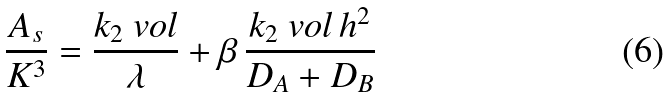<formula> <loc_0><loc_0><loc_500><loc_500>\frac { A _ { s } } { K ^ { 3 } } = \frac { k _ { 2 } \ v o l } { \lambda } + \beta \, \frac { k _ { 2 } \ v o l \, h ^ { 2 } } { D _ { A } + D _ { B } }</formula> 